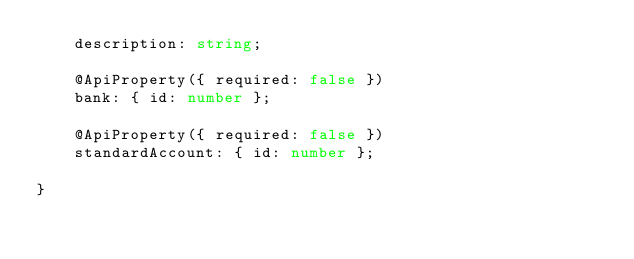Convert code to text. <code><loc_0><loc_0><loc_500><loc_500><_TypeScript_>    description: string;

    @ApiProperty({ required: false })
    bank: { id: number };

    @ApiProperty({ required: false })
    standardAccount: { id: number };

}
</code> 